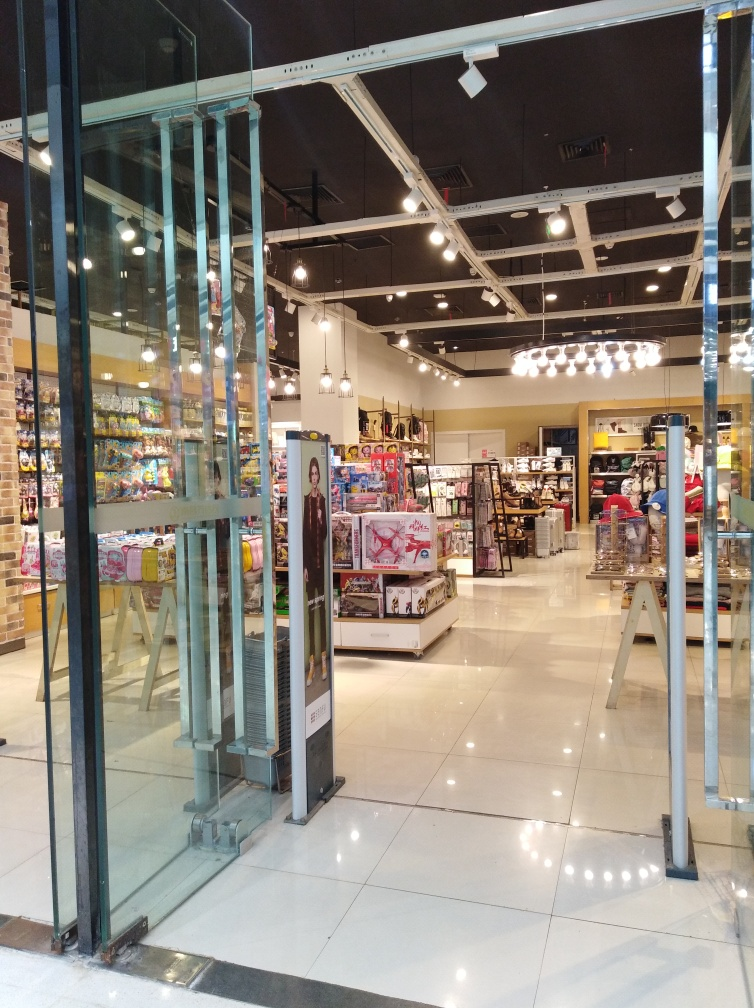Can you describe the type of store and items that are on display? Certainly! This is a retail store specializing in pop culture merchandise, which includes collectibles, toys, and likely branded apparel. The displays are well-organized, showcasing a variety of figurines, boxed items, and other collectible pieces that may appeal to fans of various franchises and characters. Are there any particular themes or popular franchises you can identify? While specific brands cannot be identified from this perspective, the store clearly caters to a diverse array of interests, likely including mainstream entertainment properties like superhero films, animated series, and sci-fi or fantasy universes. 